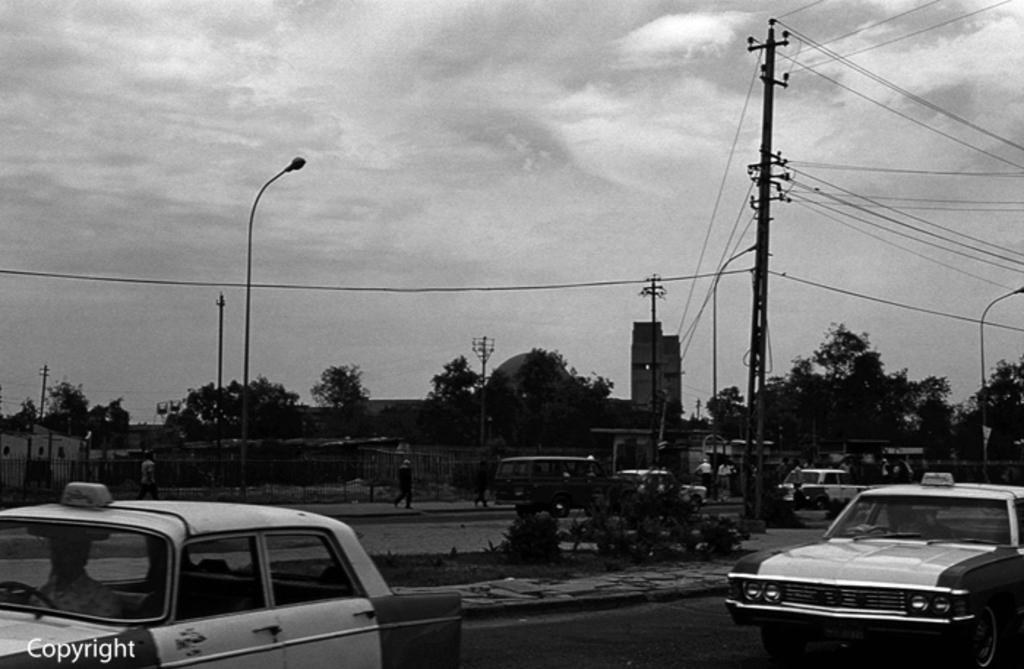Can you describe this image briefly? It is a black and white picture. In the center of the image we can see a few vehicles on the road. At the bottom left side of the image, we can see some text. In the background, we can see the sky, clouds, poles, buildings, fences, wires, trees, plants, few people and a few other objects. 